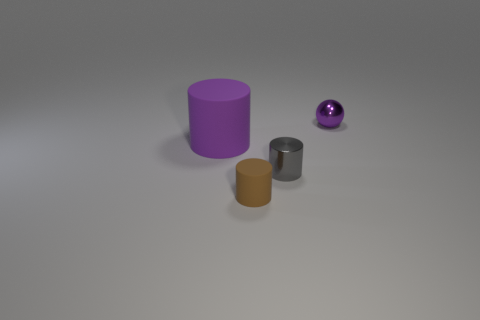Subtract all shiny cylinders. How many cylinders are left? 2 Subtract all gray cylinders. How many cylinders are left? 2 Add 4 tiny brown matte things. How many objects exist? 8 Subtract all blue cylinders. Subtract all green cubes. How many cylinders are left? 3 Subtract all cylinders. How many objects are left? 1 Subtract all small green shiny cylinders. Subtract all shiny objects. How many objects are left? 2 Add 1 tiny spheres. How many tiny spheres are left? 2 Add 3 brown rubber things. How many brown rubber things exist? 4 Subtract 1 brown cylinders. How many objects are left? 3 